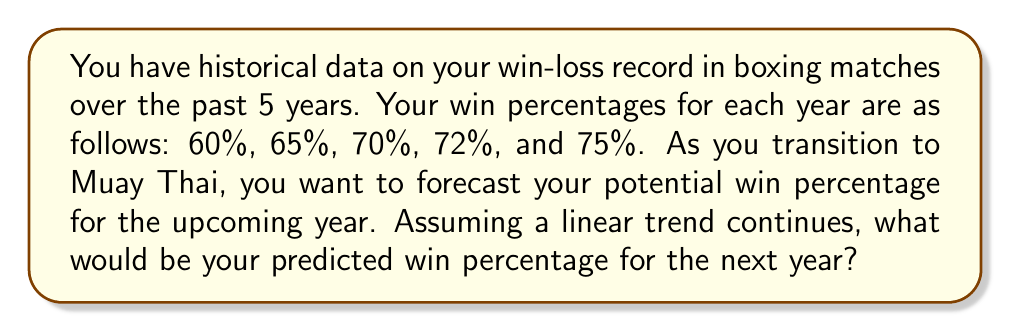Can you answer this question? To forecast the win percentage for the upcoming year, we can use a simple linear regression model based on the historical data. Let's follow these steps:

1. Assign time values to each year:
   Year 1: t = 0, Win% = 60%
   Year 2: t = 1, Win% = 65%
   Year 3: t = 2, Win% = 70%
   Year 4: t = 3, Win% = 72%
   Year 5: t = 4, Win% = 75%

2. Calculate the means of t and Win%:
   $\bar{t} = \frac{0 + 1 + 2 + 3 + 4}{5} = 2$
   $\overline{\text{Win%}} = \frac{60 + 65 + 70 + 72 + 75}{5} = 68.4$

3. Calculate the slope (b) of the regression line:
   $$b = \frac{\sum(t_i - \bar{t})(\text{Win%}_i - \overline{\text{Win%}})}{\sum(t_i - \bar{t})^2}$$

   $\sum(t_i - \bar{t})(\text{Win%}_i - \overline{\text{Win%}}) = (-2)(-8.4) + (-1)(-3.4) + (0)(1.6) + (1)(3.6) + (2)(6.6) = 36.8$
   $\sum(t_i - \bar{t})^2 = (-2)^2 + (-1)^2 + 0^2 + 1^2 + 2^2 = 10$

   $b = \frac{36.8}{10} = 3.68$

4. Calculate the y-intercept (a):
   $a = \overline{\text{Win%}} - b\bar{t} = 68.4 - 3.68(2) = 61.04$

5. The regression line equation is:
   $\text{Win%} = 61.04 + 3.68t$

6. To predict the win percentage for the next year (Year 6, t = 5):
   $\text{Win%}_6 = 61.04 + 3.68(5) = 79.44$

Therefore, the predicted win percentage for the upcoming year is approximately 79.44%.
Answer: 79.44% 